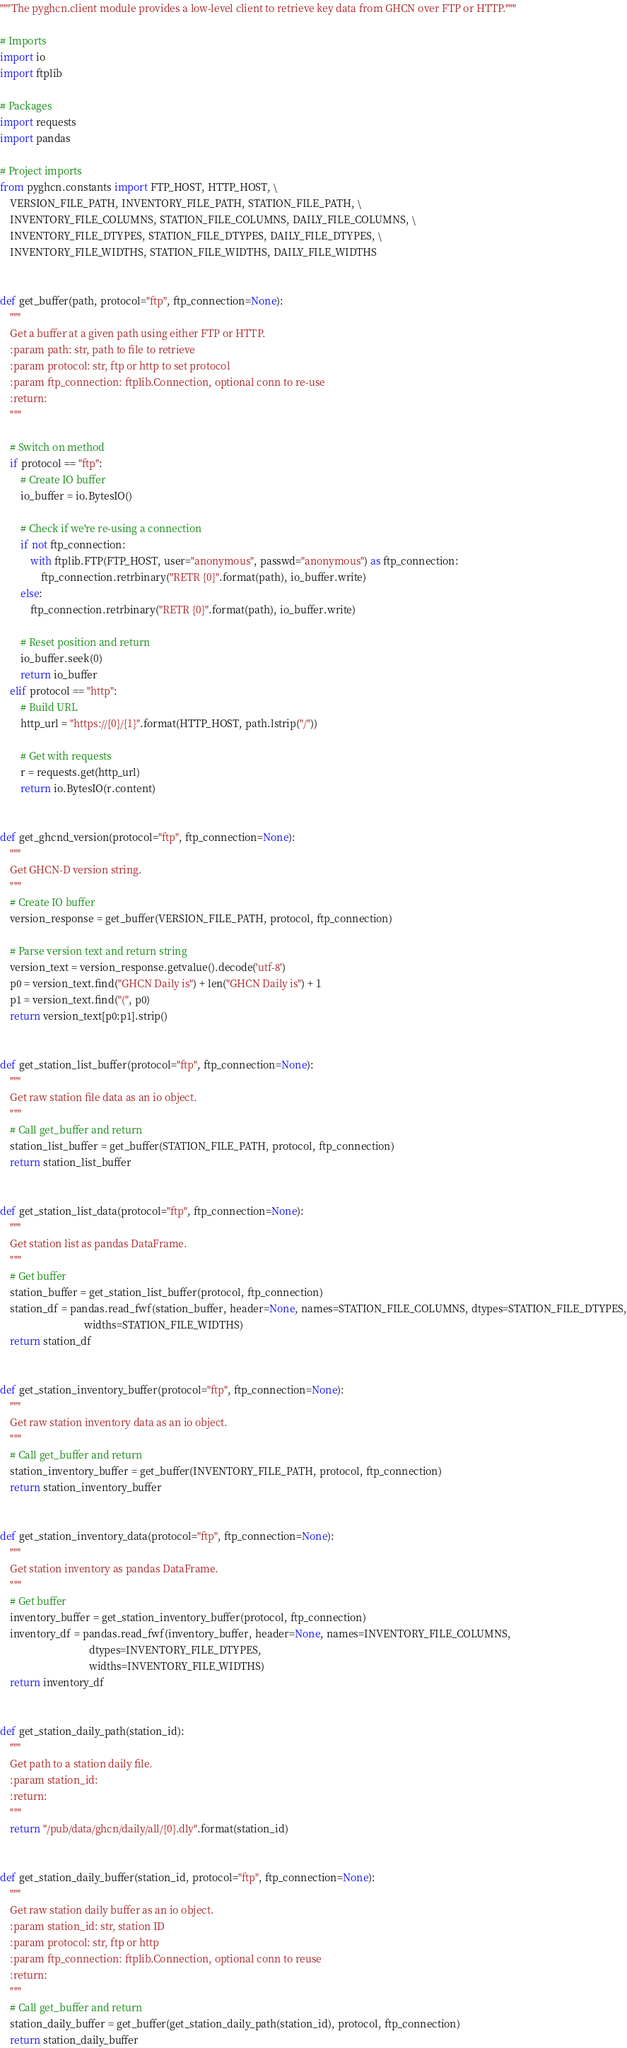Convert code to text. <code><loc_0><loc_0><loc_500><loc_500><_Python_>"""The pyghcn.client module provides a low-level client to retrieve key data from GHCN over FTP or HTTP."""

# Imports
import io
import ftplib

# Packages
import requests
import pandas

# Project imports
from pyghcn.constants import FTP_HOST, HTTP_HOST, \
    VERSION_FILE_PATH, INVENTORY_FILE_PATH, STATION_FILE_PATH, \
    INVENTORY_FILE_COLUMNS, STATION_FILE_COLUMNS, DAILY_FILE_COLUMNS, \
    INVENTORY_FILE_DTYPES, STATION_FILE_DTYPES, DAILY_FILE_DTYPES, \
    INVENTORY_FILE_WIDTHS, STATION_FILE_WIDTHS, DAILY_FILE_WIDTHS


def get_buffer(path, protocol="ftp", ftp_connection=None):
    """
    Get a buffer at a given path using either FTP or HTTP.
    :param path: str, path to file to retrieve
    :param protocol: str, ftp or http to set protocol
    :param ftp_connection: ftplib.Connection, optional conn to re-use
    :return:
    """

    # Switch on method
    if protocol == "ftp":
        # Create IO buffer
        io_buffer = io.BytesIO()

        # Check if we're re-using a connection
        if not ftp_connection:
            with ftplib.FTP(FTP_HOST, user="anonymous", passwd="anonymous") as ftp_connection:
                ftp_connection.retrbinary("RETR {0}".format(path), io_buffer.write)
        else:
            ftp_connection.retrbinary("RETR {0}".format(path), io_buffer.write)

        # Reset position and return
        io_buffer.seek(0)
        return io_buffer
    elif protocol == "http":
        # Build URL
        http_url = "https://{0}/{1}".format(HTTP_HOST, path.lstrip("/"))

        # Get with requests
        r = requests.get(http_url)
        return io.BytesIO(r.content)


def get_ghcnd_version(protocol="ftp", ftp_connection=None):
    """
    Get GHCN-D version string.
    """
    # Create IO buffer
    version_response = get_buffer(VERSION_FILE_PATH, protocol, ftp_connection)

    # Parse version text and return string
    version_text = version_response.getvalue().decode('utf-8')
    p0 = version_text.find("GHCN Daily is") + len("GHCN Daily is") + 1
    p1 = version_text.find("(", p0)
    return version_text[p0:p1].strip()


def get_station_list_buffer(protocol="ftp", ftp_connection=None):
    """
    Get raw station file data as an io object.
    """
    # Call get_buffer and return
    station_list_buffer = get_buffer(STATION_FILE_PATH, protocol, ftp_connection)
    return station_list_buffer


def get_station_list_data(protocol="ftp", ftp_connection=None):
    """
    Get station list as pandas DataFrame.
    """
    # Get buffer
    station_buffer = get_station_list_buffer(protocol, ftp_connection)
    station_df = pandas.read_fwf(station_buffer, header=None, names=STATION_FILE_COLUMNS, dtypes=STATION_FILE_DTYPES,
                                 widths=STATION_FILE_WIDTHS)
    return station_df


def get_station_inventory_buffer(protocol="ftp", ftp_connection=None):
    """
    Get raw station inventory data as an io object.
    """
    # Call get_buffer and return
    station_inventory_buffer = get_buffer(INVENTORY_FILE_PATH, protocol, ftp_connection)
    return station_inventory_buffer


def get_station_inventory_data(protocol="ftp", ftp_connection=None):
    """
    Get station inventory as pandas DataFrame.
    """
    # Get buffer
    inventory_buffer = get_station_inventory_buffer(protocol, ftp_connection)
    inventory_df = pandas.read_fwf(inventory_buffer, header=None, names=INVENTORY_FILE_COLUMNS,
                                   dtypes=INVENTORY_FILE_DTYPES,
                                   widths=INVENTORY_FILE_WIDTHS)
    return inventory_df


def get_station_daily_path(station_id):
    """
    Get path to a station daily file.
    :param station_id:
    :return:
    """
    return "/pub/data/ghcn/daily/all/{0}.dly".format(station_id)


def get_station_daily_buffer(station_id, protocol="ftp", ftp_connection=None):
    """
    Get raw station daily buffer as an io object.
    :param station_id: str, station ID
    :param protocol: str, ftp or http
    :param ftp_connection: ftplib.Connection, optional conn to reuse
    :return:
    """
    # Call get_buffer and return
    station_daily_buffer = get_buffer(get_station_daily_path(station_id), protocol, ftp_connection)
    return station_daily_buffer

</code> 